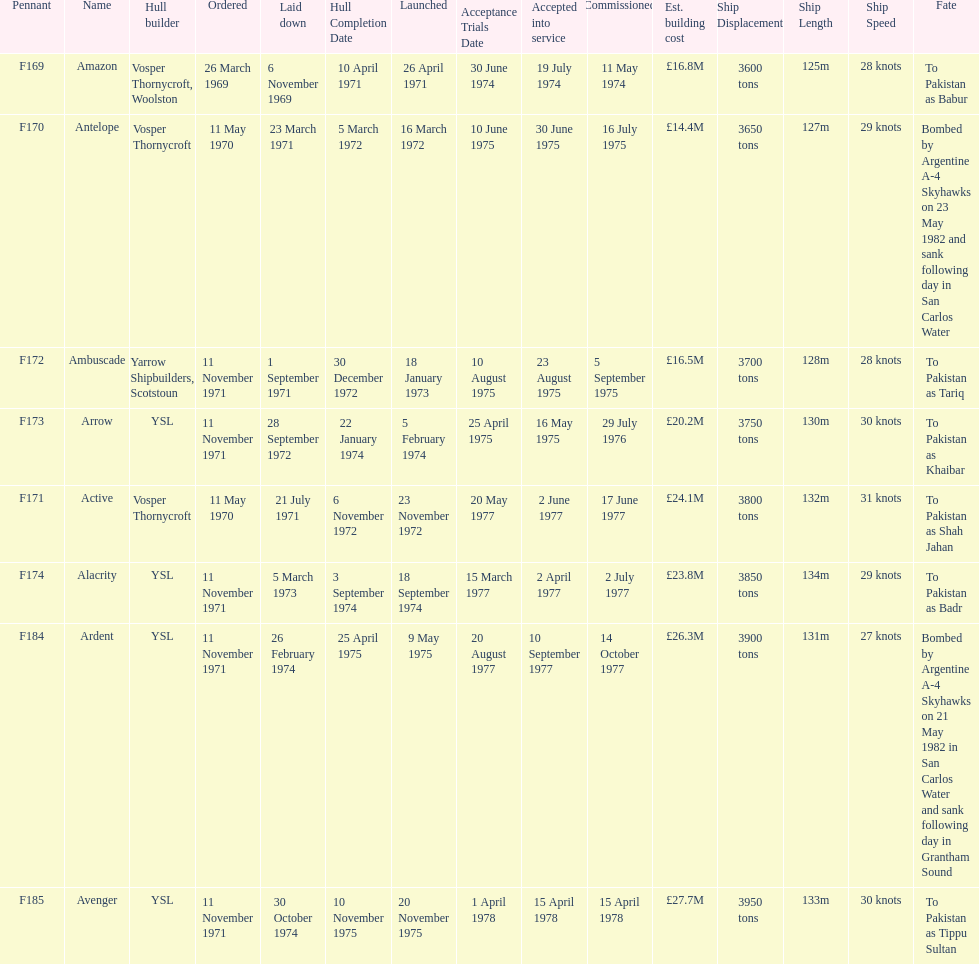What is the last listed pennant? F185. 